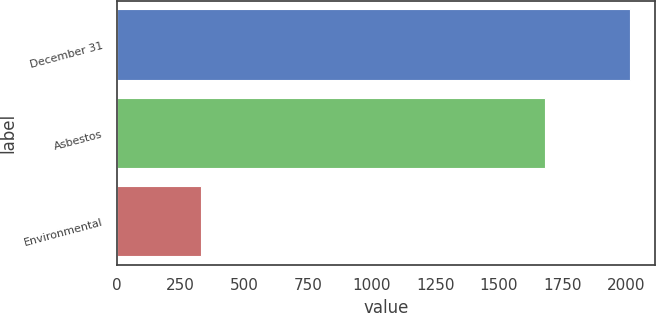Convert chart. <chart><loc_0><loc_0><loc_500><loc_500><bar_chart><fcel>December 31<fcel>Asbestos<fcel>Environmental<nl><fcel>2015<fcel>1680<fcel>331<nl></chart> 